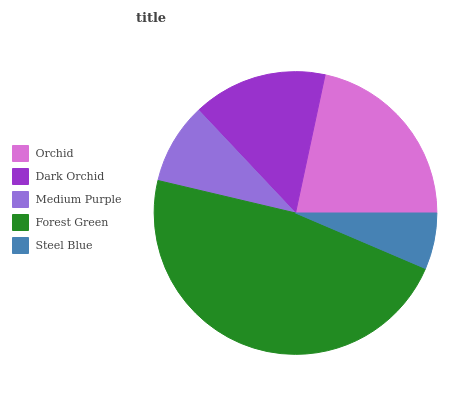Is Steel Blue the minimum?
Answer yes or no. Yes. Is Forest Green the maximum?
Answer yes or no. Yes. Is Dark Orchid the minimum?
Answer yes or no. No. Is Dark Orchid the maximum?
Answer yes or no. No. Is Orchid greater than Dark Orchid?
Answer yes or no. Yes. Is Dark Orchid less than Orchid?
Answer yes or no. Yes. Is Dark Orchid greater than Orchid?
Answer yes or no. No. Is Orchid less than Dark Orchid?
Answer yes or no. No. Is Dark Orchid the high median?
Answer yes or no. Yes. Is Dark Orchid the low median?
Answer yes or no. Yes. Is Orchid the high median?
Answer yes or no. No. Is Medium Purple the low median?
Answer yes or no. No. 